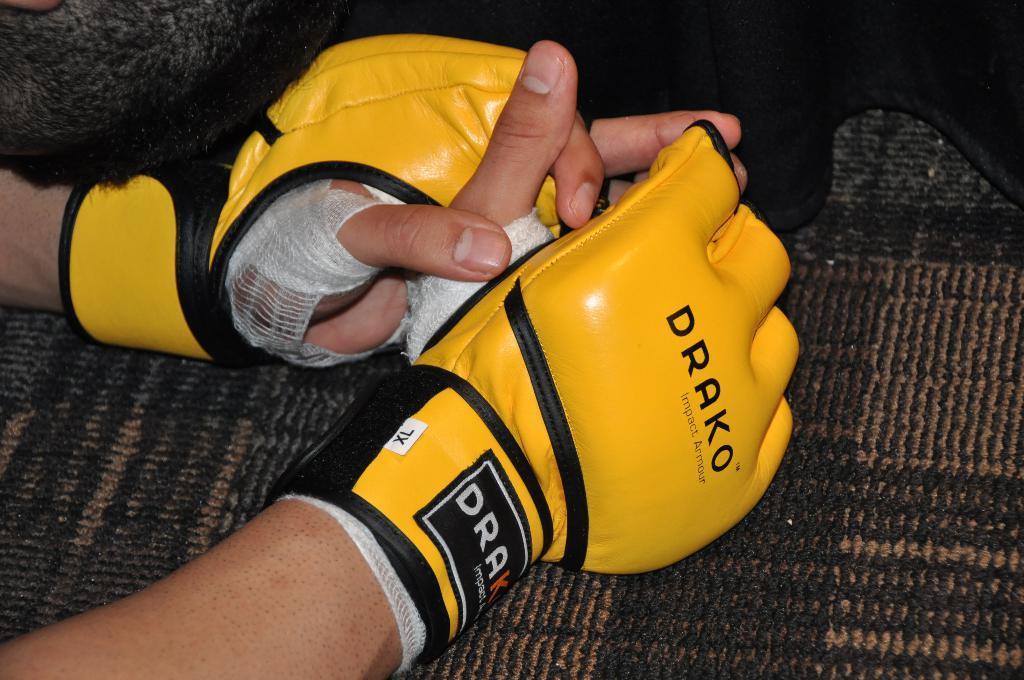Could you give a brief overview of what you see in this image? In the image there are two hands of a person wearing gloves. 